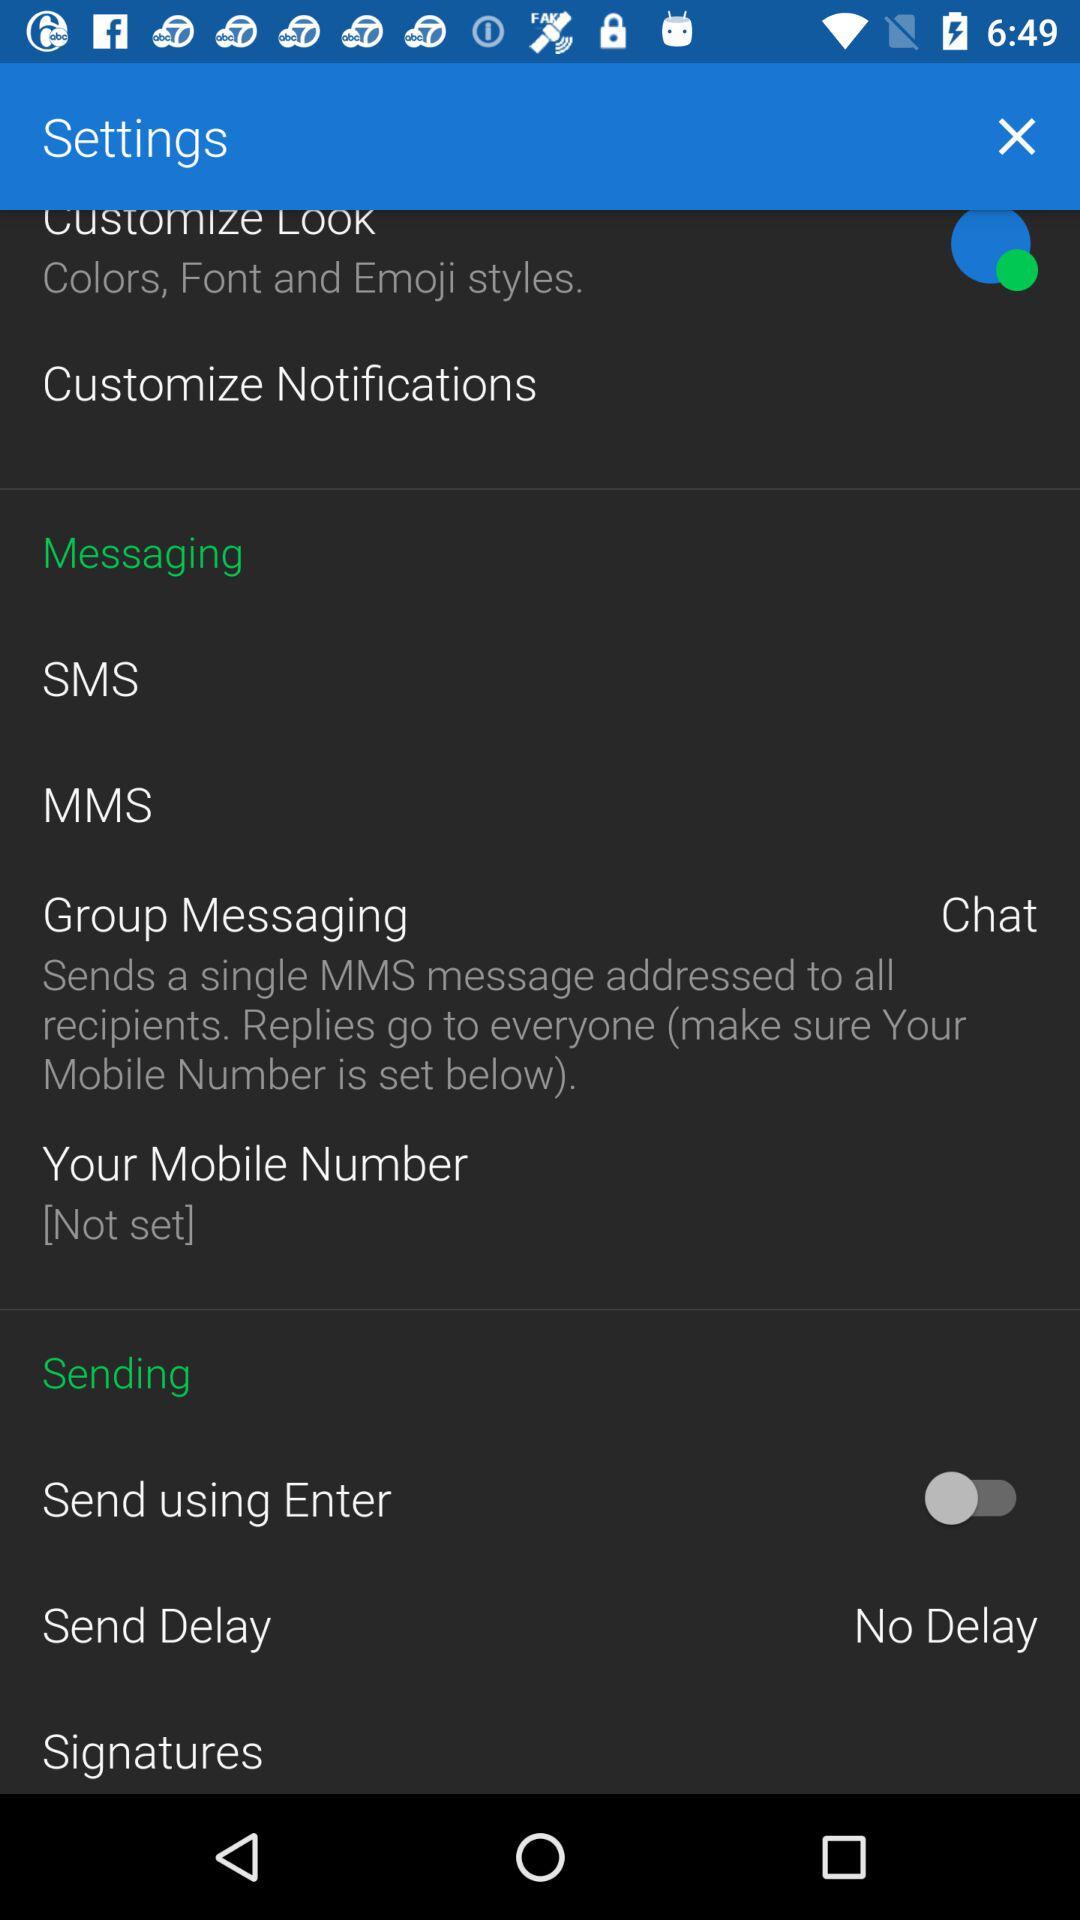What is the setting for "Send Delay"? The setting for "Send Delay" is set to No Delay. 